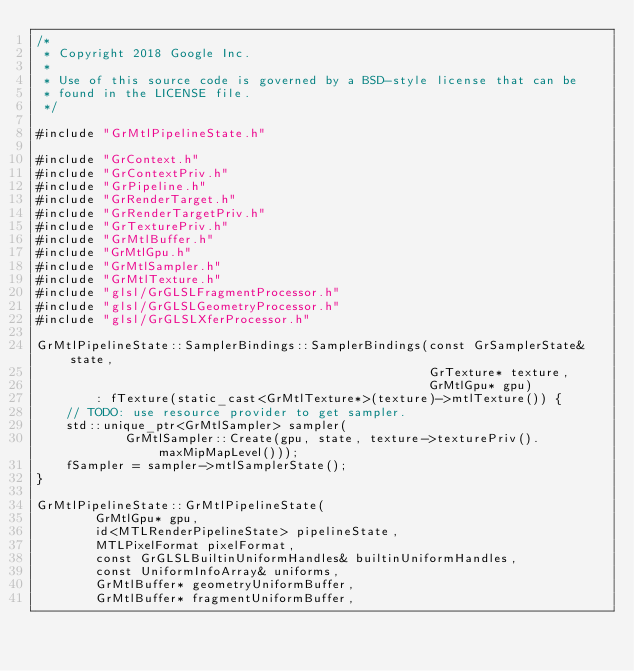<code> <loc_0><loc_0><loc_500><loc_500><_ObjectiveC_>/*
 * Copyright 2018 Google Inc.
 *
 * Use of this source code is governed by a BSD-style license that can be
 * found in the LICENSE file.
 */

#include "GrMtlPipelineState.h"

#include "GrContext.h"
#include "GrContextPriv.h"
#include "GrPipeline.h"
#include "GrRenderTarget.h"
#include "GrRenderTargetPriv.h"
#include "GrTexturePriv.h"
#include "GrMtlBuffer.h"
#include "GrMtlGpu.h"
#include "GrMtlSampler.h"
#include "GrMtlTexture.h"
#include "glsl/GrGLSLFragmentProcessor.h"
#include "glsl/GrGLSLGeometryProcessor.h"
#include "glsl/GrGLSLXferProcessor.h"

GrMtlPipelineState::SamplerBindings::SamplerBindings(const GrSamplerState& state,
                                                     GrTexture* texture,
                                                     GrMtlGpu* gpu)
        : fTexture(static_cast<GrMtlTexture*>(texture)->mtlTexture()) {
    // TODO: use resource provider to get sampler.
    std::unique_ptr<GrMtlSampler> sampler(
            GrMtlSampler::Create(gpu, state, texture->texturePriv().maxMipMapLevel()));
    fSampler = sampler->mtlSamplerState();
}

GrMtlPipelineState::GrMtlPipelineState(
        GrMtlGpu* gpu,
        id<MTLRenderPipelineState> pipelineState,
        MTLPixelFormat pixelFormat,
        const GrGLSLBuiltinUniformHandles& builtinUniformHandles,
        const UniformInfoArray& uniforms,
        GrMtlBuffer* geometryUniformBuffer,
        GrMtlBuffer* fragmentUniformBuffer,</code> 